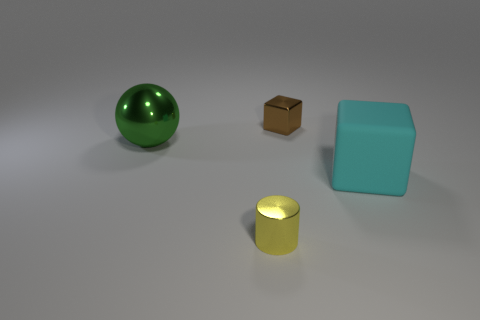Add 1 brown metallic things. How many objects exist? 5 Subtract all cylinders. How many objects are left? 3 Subtract all red spheres. Subtract all brown cylinders. How many spheres are left? 1 Subtract all purple balls. How many cyan cylinders are left? 0 Subtract all tiny blue metallic cylinders. Subtract all yellow shiny cylinders. How many objects are left? 3 Add 3 large rubber blocks. How many large rubber blocks are left? 4 Add 3 shiny cylinders. How many shiny cylinders exist? 4 Subtract 1 yellow cylinders. How many objects are left? 3 